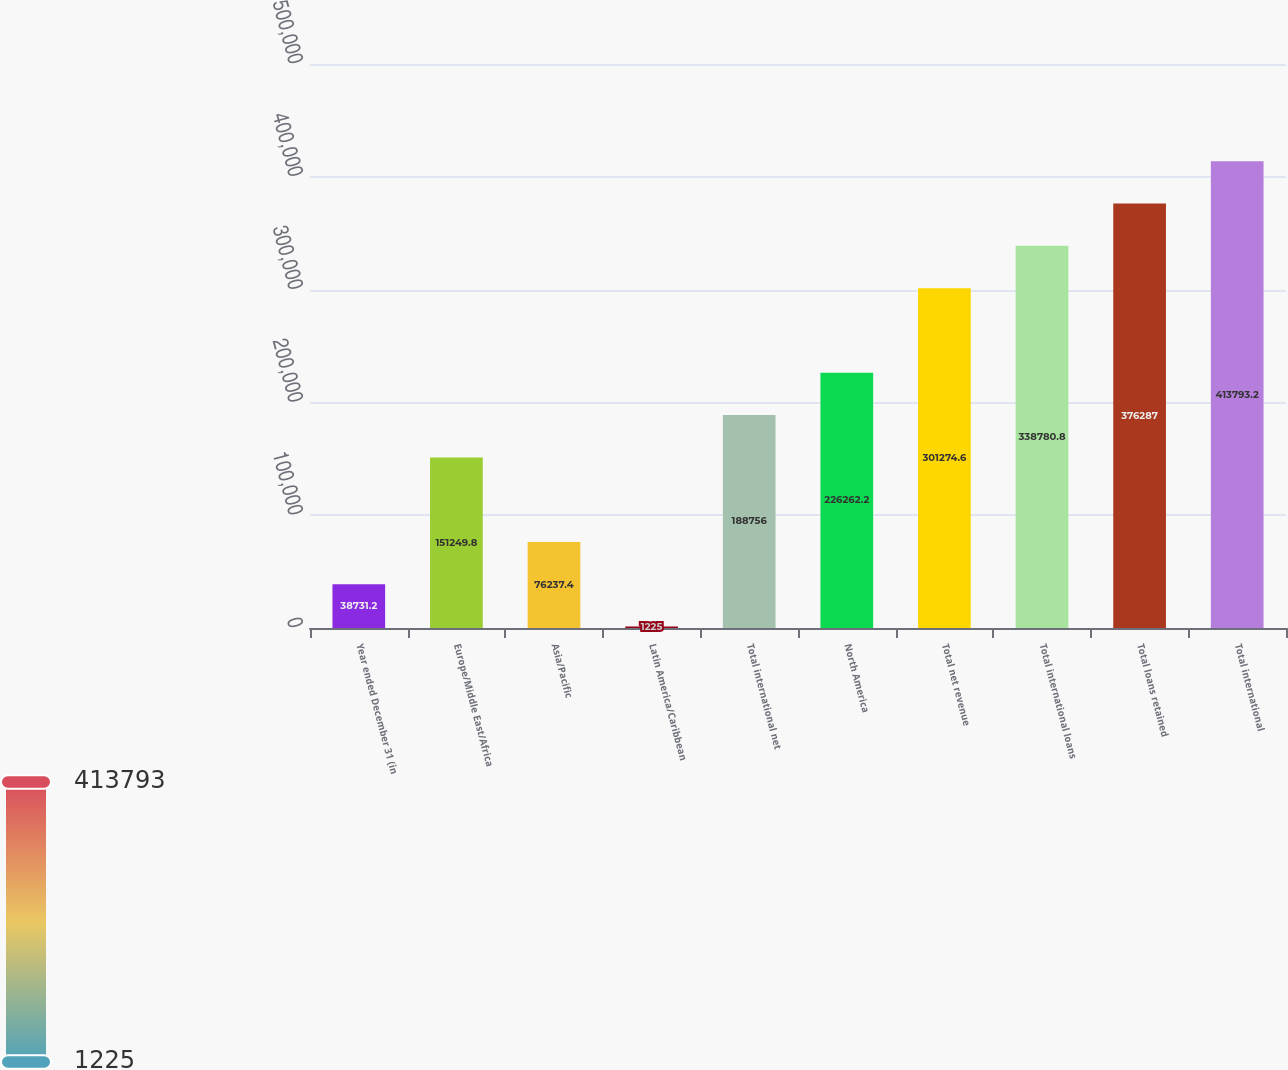<chart> <loc_0><loc_0><loc_500><loc_500><bar_chart><fcel>Year ended December 31 (in<fcel>Europe/Middle East/Africa<fcel>Asia/Pacific<fcel>Latin America/Caribbean<fcel>Total international net<fcel>North America<fcel>Total net revenue<fcel>Total international loans<fcel>Total loans retained<fcel>Total international<nl><fcel>38731.2<fcel>151250<fcel>76237.4<fcel>1225<fcel>188756<fcel>226262<fcel>301275<fcel>338781<fcel>376287<fcel>413793<nl></chart> 